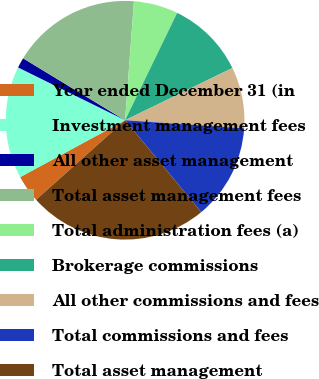Convert chart. <chart><loc_0><loc_0><loc_500><loc_500><pie_chart><fcel>Year ended December 31 (in<fcel>Investment management fees<fcel>All other asset management<fcel>Total asset management fees<fcel>Total administration fees (a)<fcel>Brokerage commissions<fcel>All other commissions and fees<fcel>Total commissions and fees<fcel>Total asset management<nl><fcel>3.7%<fcel>15.2%<fcel>1.39%<fcel>17.5%<fcel>6.0%<fcel>10.6%<fcel>8.3%<fcel>12.9%<fcel>24.41%<nl></chart> 